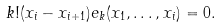Convert formula to latex. <formula><loc_0><loc_0><loc_500><loc_500>k ! ( x _ { i } - x _ { i + 1 } ) e _ { k } ( x _ { 1 } , \dots , x _ { i } ) = 0 .</formula> 